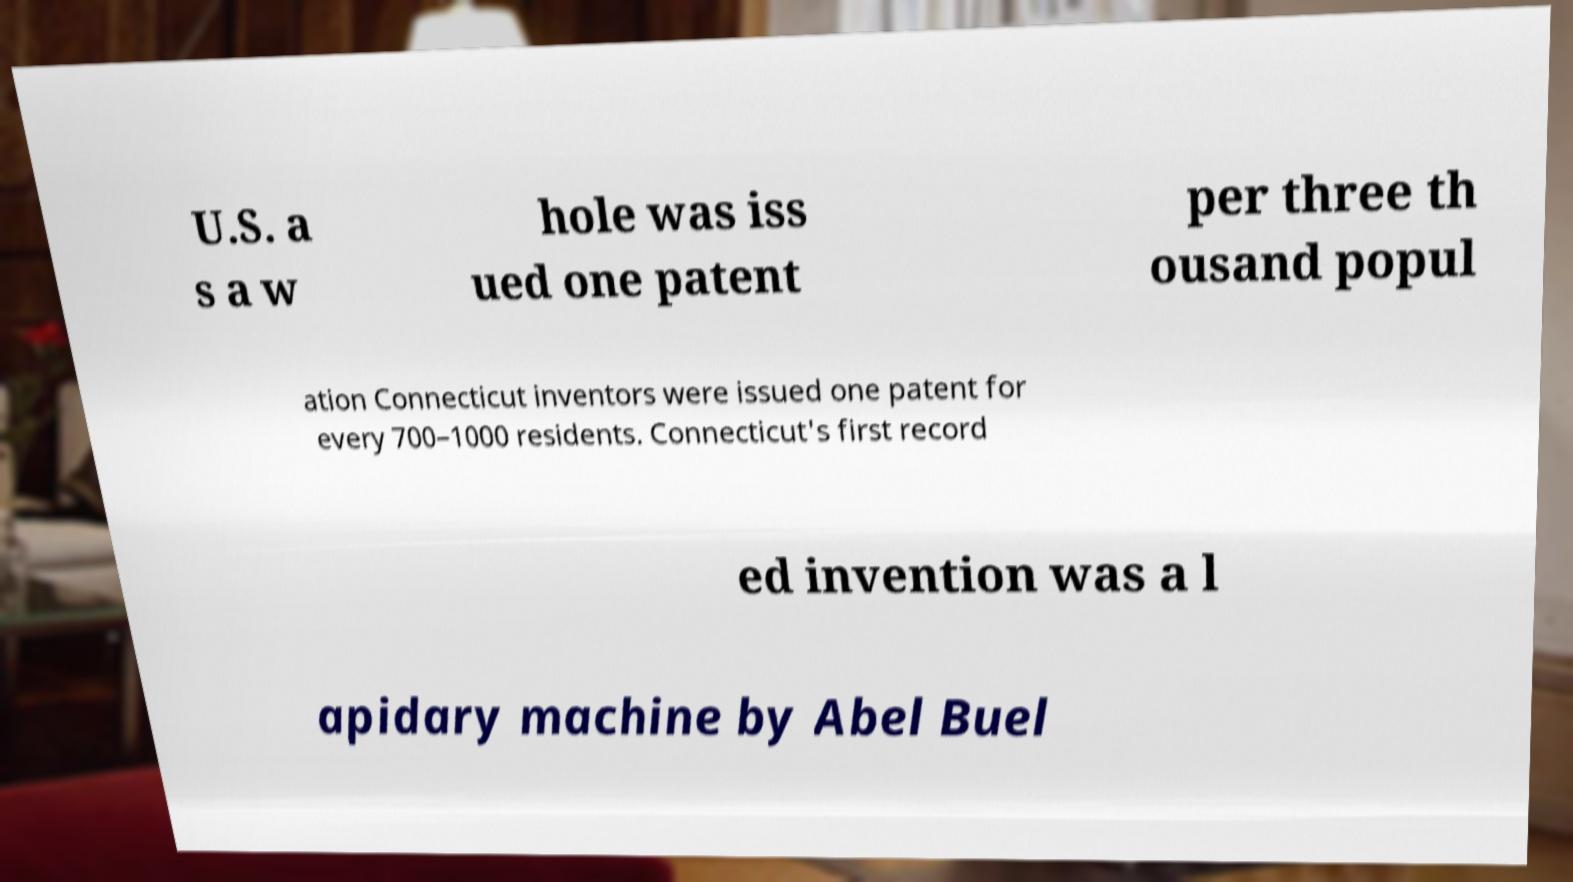Can you read and provide the text displayed in the image?This photo seems to have some interesting text. Can you extract and type it out for me? U.S. a s a w hole was iss ued one patent per three th ousand popul ation Connecticut inventors were issued one patent for every 700–1000 residents. Connecticut's first record ed invention was a l apidary machine by Abel Buel 